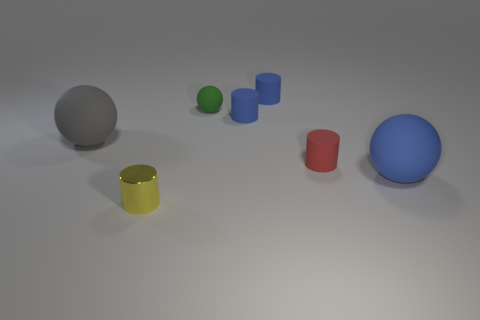Add 1 blue cylinders. How many objects exist? 8 Subtract all cylinders. How many objects are left? 3 Subtract 0 brown cylinders. How many objects are left? 7 Subtract all small red matte cubes. Subtract all big blue things. How many objects are left? 6 Add 4 large gray things. How many large gray things are left? 5 Add 1 large blue spheres. How many large blue spheres exist? 2 